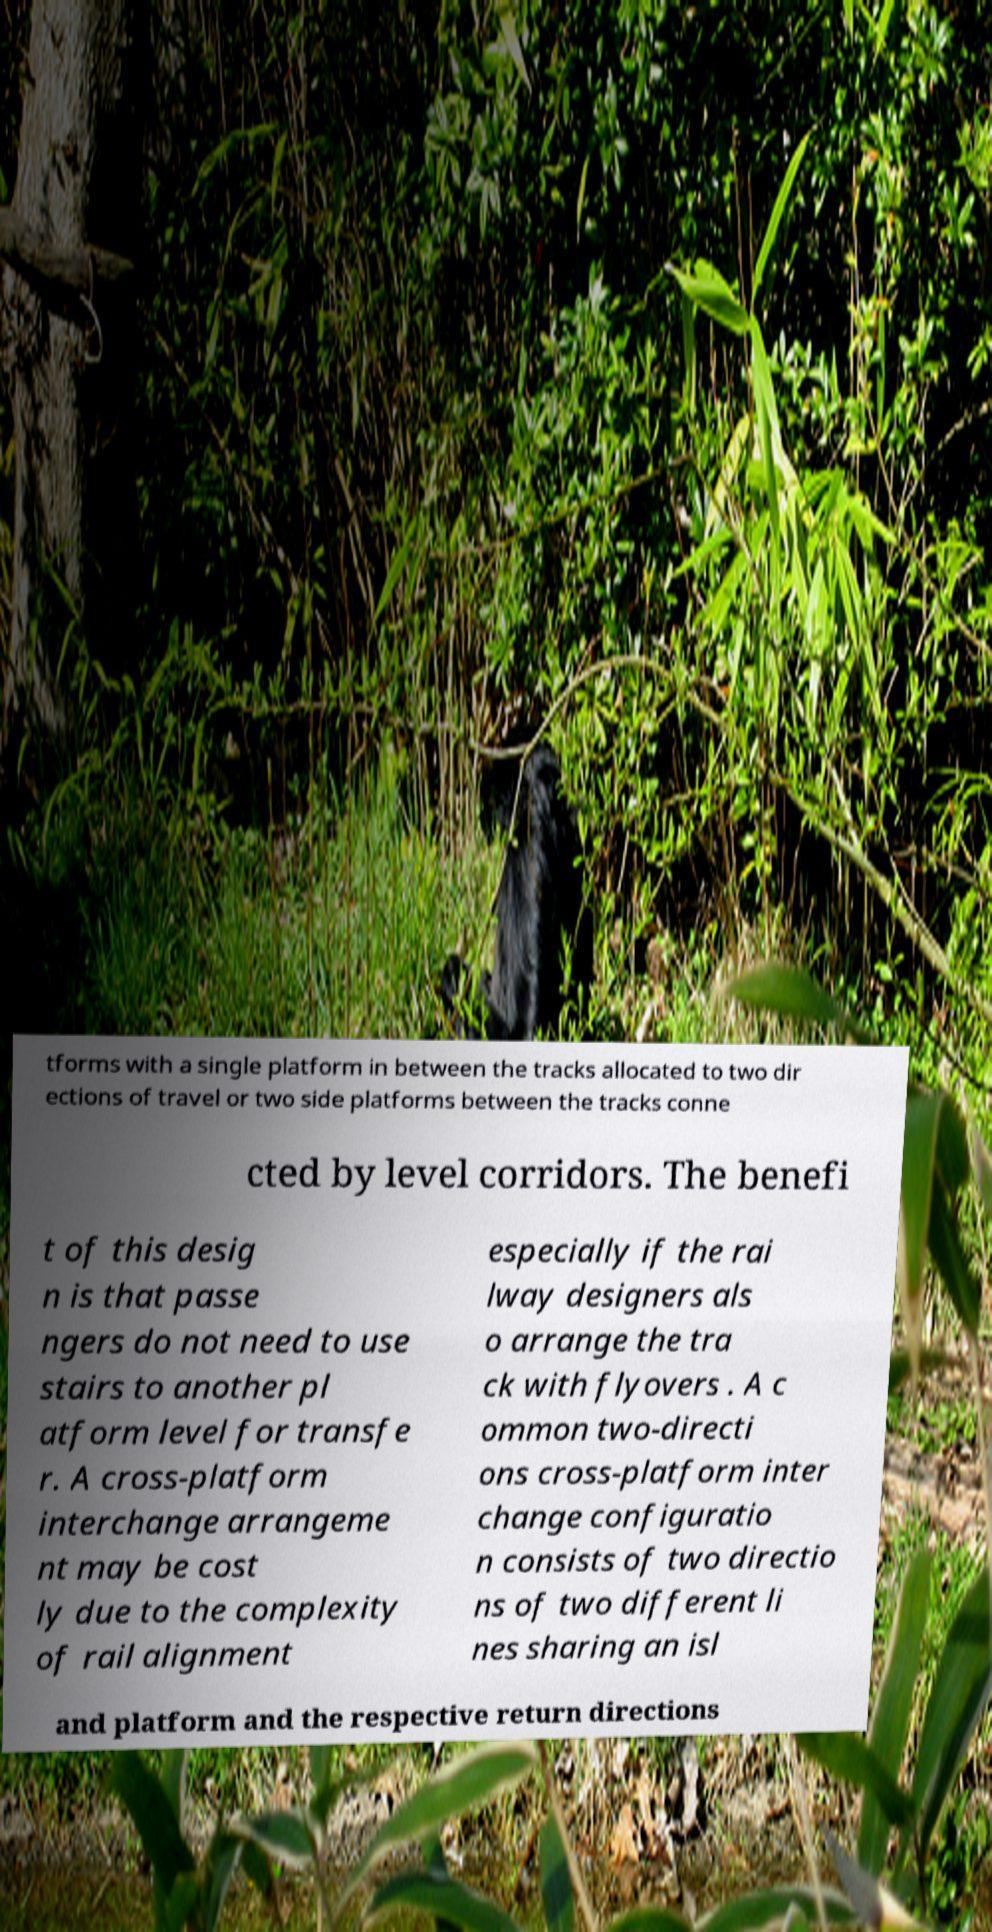Could you extract and type out the text from this image? tforms with a single platform in between the tracks allocated to two dir ections of travel or two side platforms between the tracks conne cted by level corridors. The benefi t of this desig n is that passe ngers do not need to use stairs to another pl atform level for transfe r. A cross-platform interchange arrangeme nt may be cost ly due to the complexity of rail alignment especially if the rai lway designers als o arrange the tra ck with flyovers . A c ommon two-directi ons cross-platform inter change configuratio n consists of two directio ns of two different li nes sharing an isl and platform and the respective return directions 